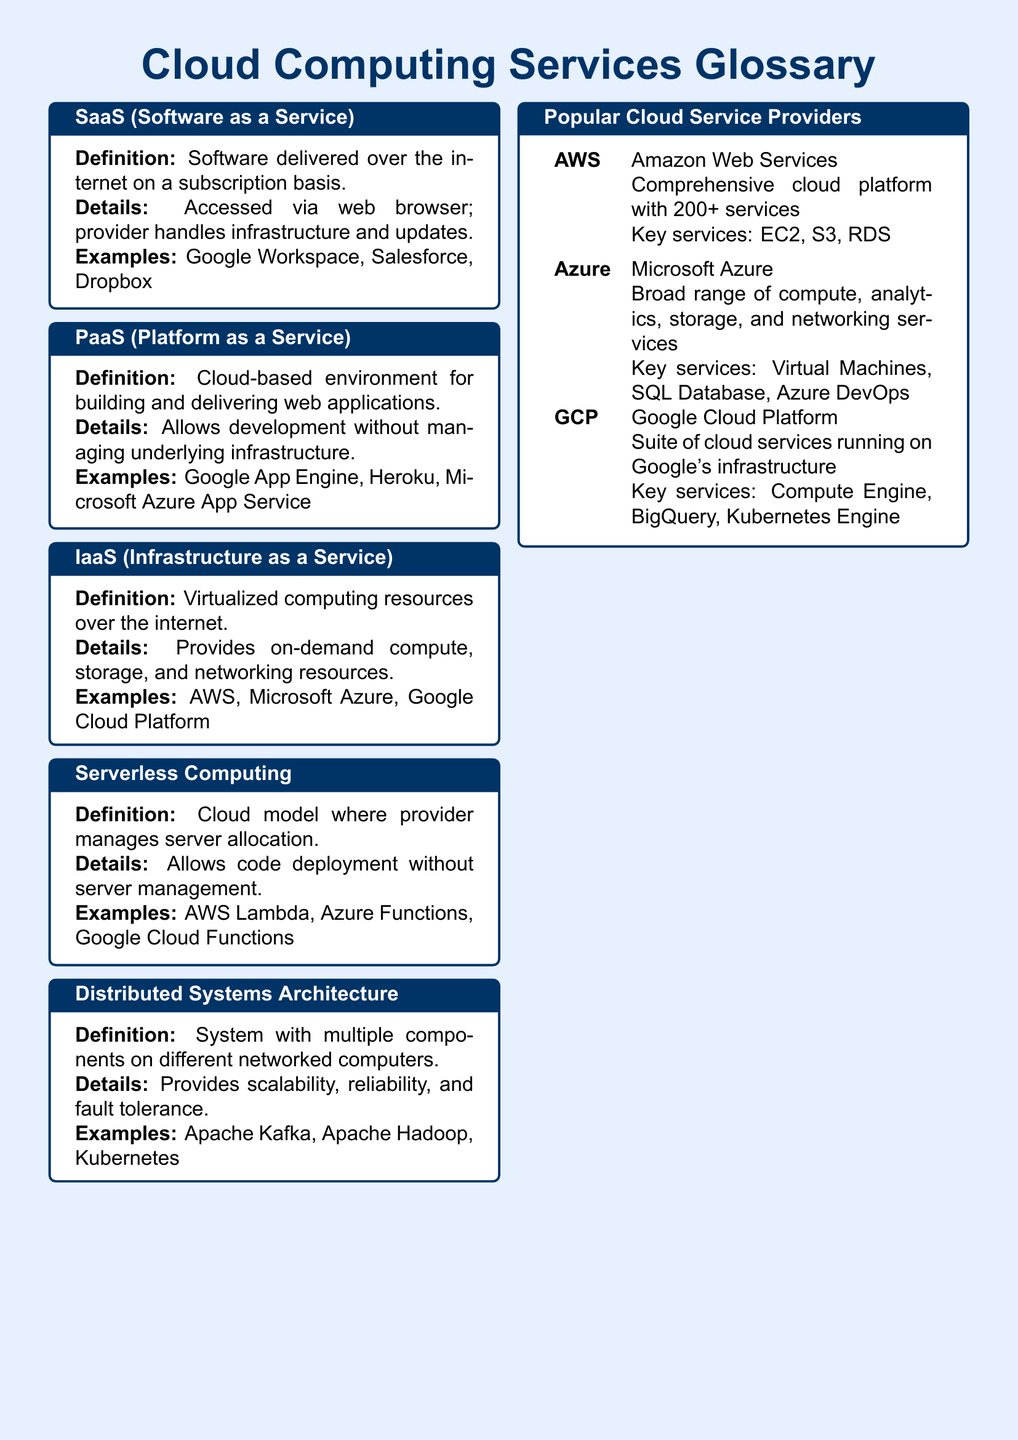What does SaaS stand for? SaaS is defined as Software as a Service in the document.
Answer: Software as a Service What is an example of PaaS? The document lists Google App Engine as an example of PaaS.
Answer: Google App Engine What are key services of AWS? Key services of AWS mentioned in the document include EC2, S3, and RDS.
Answer: EC2, S3, RDS What is the definition of IaaS? IaaS is defined as virtualized computing resources over the internet in the document.
Answer: Virtualized computing resources over the internet How does serverless computing function? Serverless computing allows code deployment without server management according to the document.
Answer: Without server management What is the purpose of distributed systems architecture? The document states that distributed systems architecture provides scalability, reliability, and fault tolerance.
Answer: Scalability, reliability, fault tolerance Which cloud service provider is associated with Azure? Microsoft's cloud service platform is referred to as Azure in the document.
Answer: Microsoft Azure What is the primary benefit of PaaS? The document indicates that PaaS allows development without managing underlying infrastructure.
Answer: Without managing underlying infrastructure 